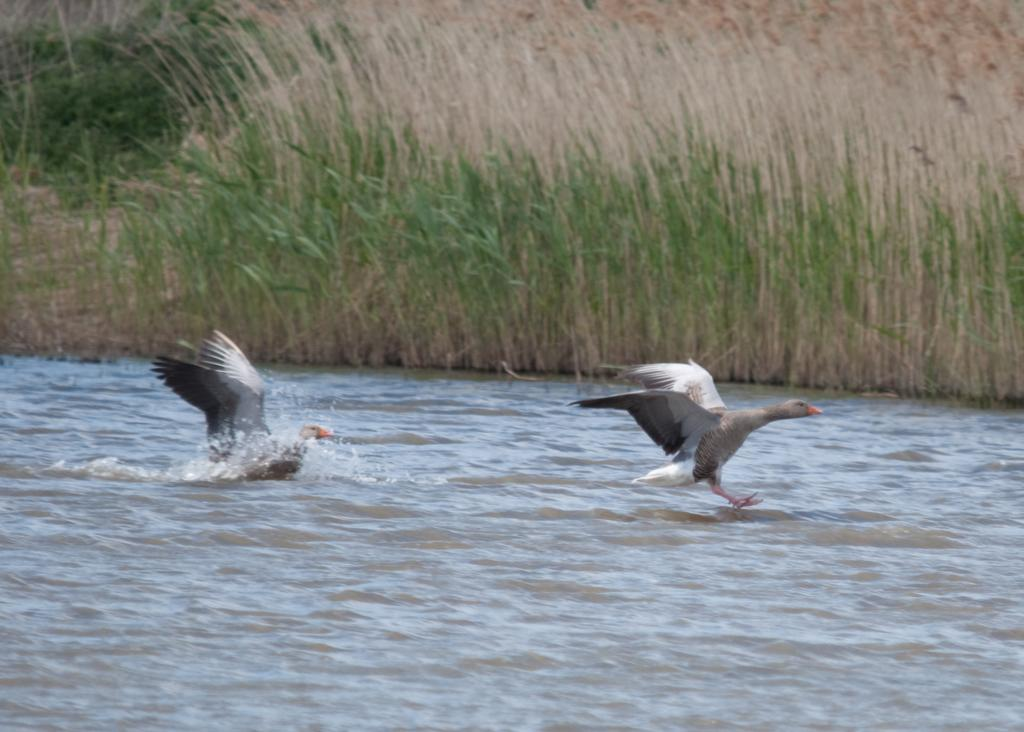What type of vegetation is present in the image? There is grass in the image. What animals can be seen in the image? There are birds in the image. What are the birds doing in the image? The birds are flying over the surface of the water. What type of paper can be seen floating in the water in the image? There is no paper present in the image; it only features grass, birds, and water. Are there any fish visible in the water in the image? There are no fish visible in the water in the image; only birds are flying over the surface. 